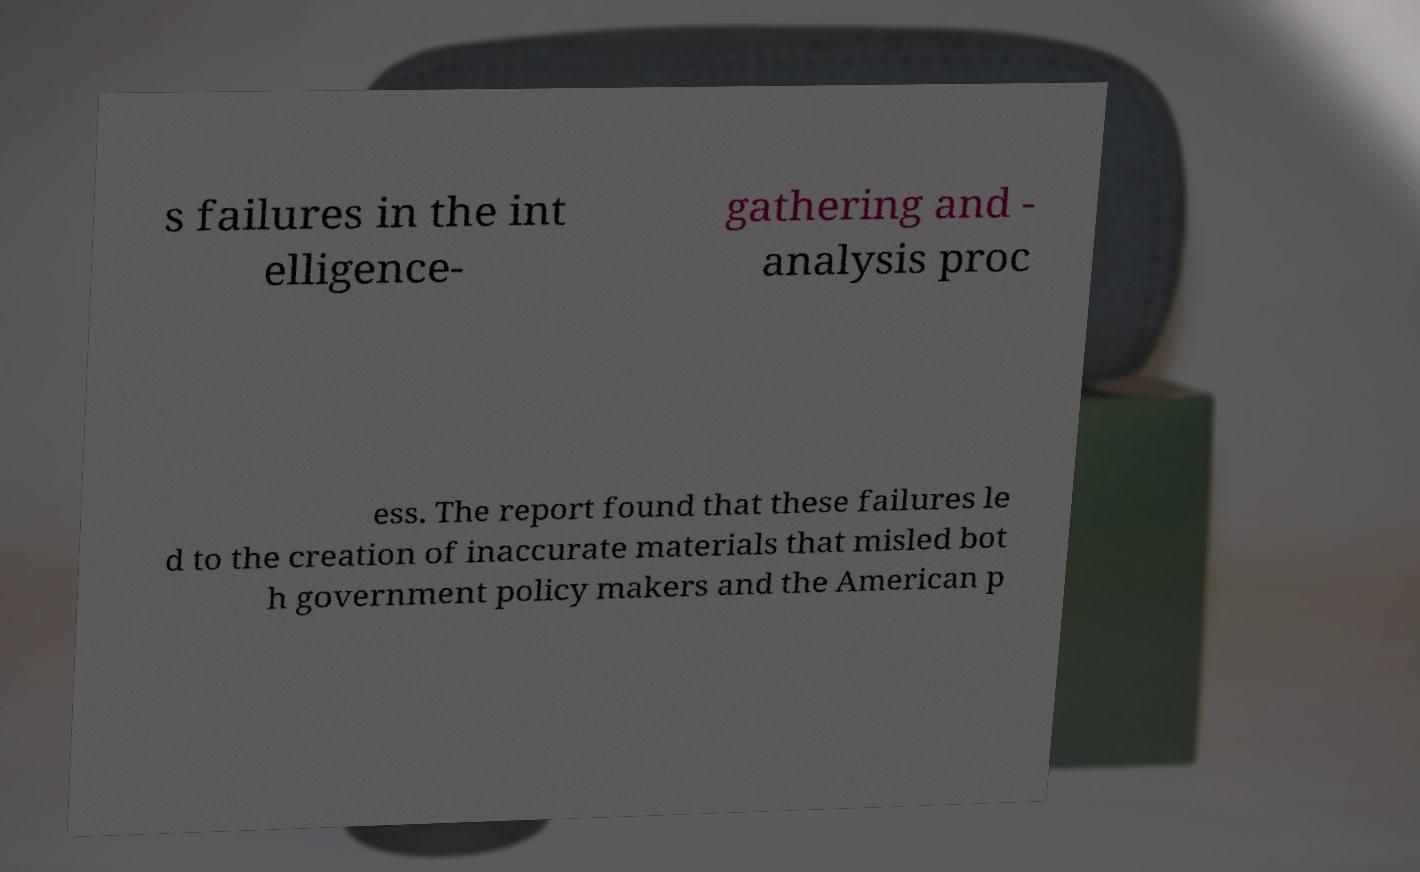Could you extract and type out the text from this image? s failures in the int elligence- gathering and - analysis proc ess. The report found that these failures le d to the creation of inaccurate materials that misled bot h government policy makers and the American p 